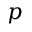<formula> <loc_0><loc_0><loc_500><loc_500>p</formula> 